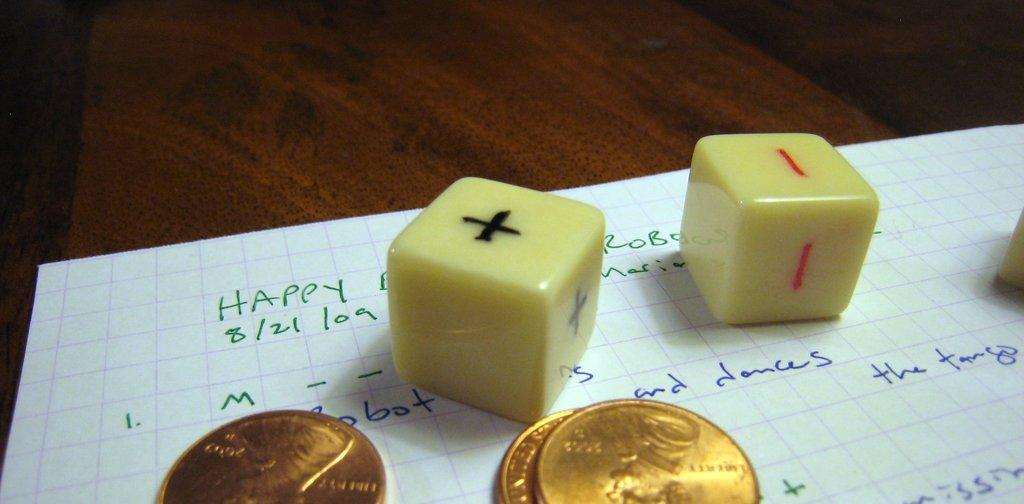Provide a one-sentence caption for the provided image. Two dice and three pennies sit on a piece of paper with the word happy written in the upper left corner. 